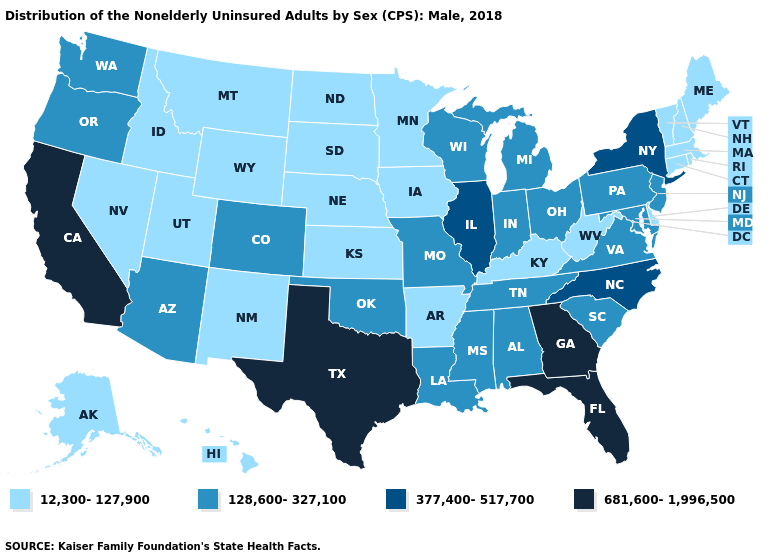Does Texas have the highest value in the USA?
Be succinct. Yes. Name the states that have a value in the range 377,400-517,700?
Write a very short answer. Illinois, New York, North Carolina. What is the value of Mississippi?
Write a very short answer. 128,600-327,100. Does Texas have the highest value in the USA?
Concise answer only. Yes. Does the first symbol in the legend represent the smallest category?
Write a very short answer. Yes. What is the highest value in the MidWest ?
Write a very short answer. 377,400-517,700. What is the value of Georgia?
Answer briefly. 681,600-1,996,500. Does the map have missing data?
Write a very short answer. No. Does Maryland have the lowest value in the USA?
Give a very brief answer. No. Name the states that have a value in the range 681,600-1,996,500?
Short answer required. California, Florida, Georgia, Texas. Which states hav the highest value in the Northeast?
Be succinct. New York. Does the map have missing data?
Write a very short answer. No. Name the states that have a value in the range 12,300-127,900?
Concise answer only. Alaska, Arkansas, Connecticut, Delaware, Hawaii, Idaho, Iowa, Kansas, Kentucky, Maine, Massachusetts, Minnesota, Montana, Nebraska, Nevada, New Hampshire, New Mexico, North Dakota, Rhode Island, South Dakota, Utah, Vermont, West Virginia, Wyoming. Which states have the lowest value in the South?
Concise answer only. Arkansas, Delaware, Kentucky, West Virginia. How many symbols are there in the legend?
Keep it brief. 4. 